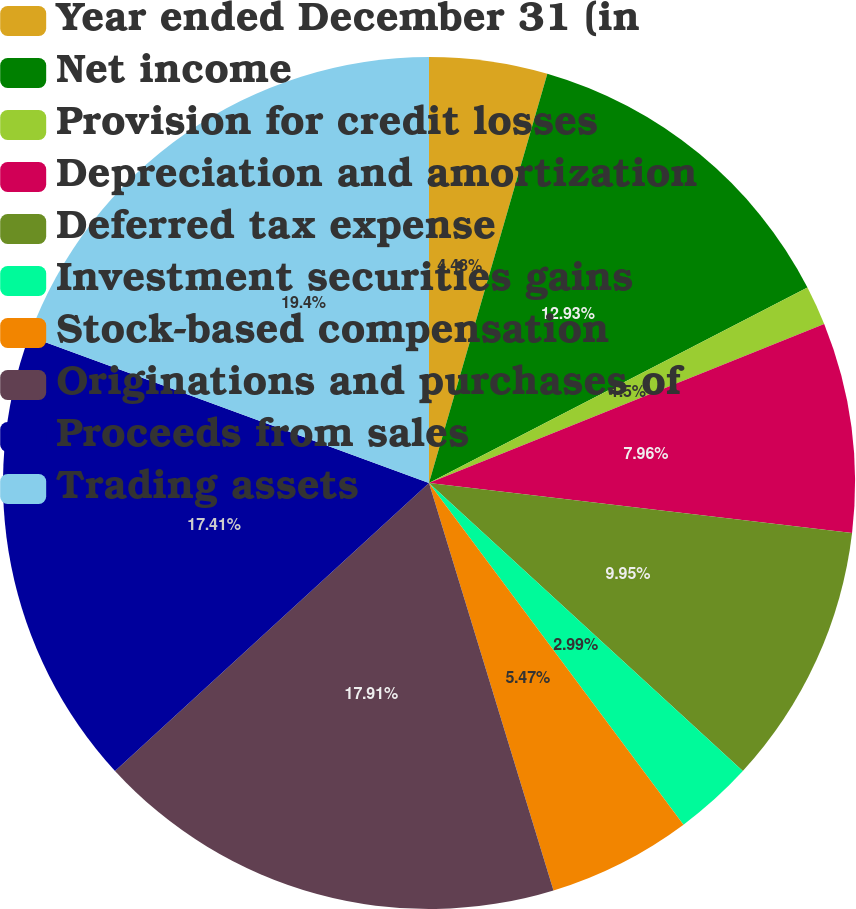Convert chart to OTSL. <chart><loc_0><loc_0><loc_500><loc_500><pie_chart><fcel>Year ended December 31 (in<fcel>Net income<fcel>Provision for credit losses<fcel>Depreciation and amortization<fcel>Deferred tax expense<fcel>Investment securities gains<fcel>Stock-based compensation<fcel>Originations and purchases of<fcel>Proceeds from sales<fcel>Trading assets<nl><fcel>4.48%<fcel>12.93%<fcel>1.5%<fcel>7.96%<fcel>9.95%<fcel>2.99%<fcel>5.47%<fcel>17.91%<fcel>17.41%<fcel>19.4%<nl></chart> 